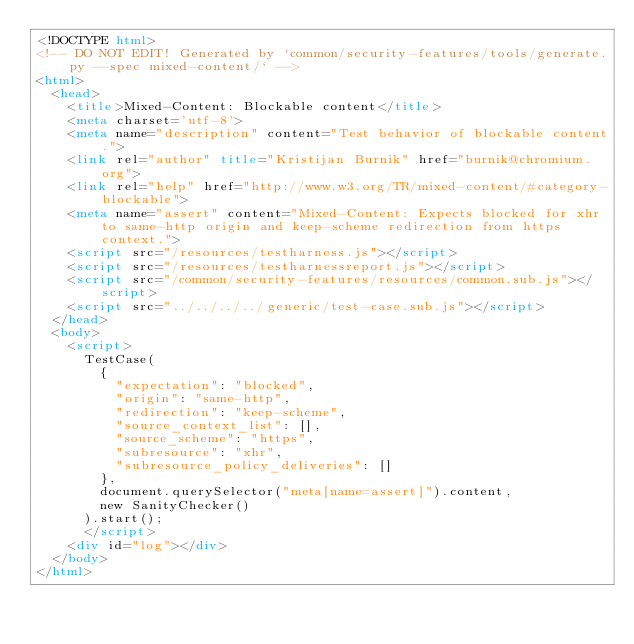Convert code to text. <code><loc_0><loc_0><loc_500><loc_500><_HTML_><!DOCTYPE html>
<!-- DO NOT EDIT! Generated by `common/security-features/tools/generate.py --spec mixed-content/` -->
<html>
  <head>
    <title>Mixed-Content: Blockable content</title>
    <meta charset='utf-8'>
    <meta name="description" content="Test behavior of blockable content.">
    <link rel="author" title="Kristijan Burnik" href="burnik@chromium.org">
    <link rel="help" href="http://www.w3.org/TR/mixed-content/#category-blockable">
    <meta name="assert" content="Mixed-Content: Expects blocked for xhr to same-http origin and keep-scheme redirection from https context.">
    <script src="/resources/testharness.js"></script>
    <script src="/resources/testharnessreport.js"></script>
    <script src="/common/security-features/resources/common.sub.js"></script>
    <script src="../../../../generic/test-case.sub.js"></script>
  </head>
  <body>
    <script>
      TestCase(
        {
          "expectation": "blocked",
          "origin": "same-http",
          "redirection": "keep-scheme",
          "source_context_list": [],
          "source_scheme": "https",
          "subresource": "xhr",
          "subresource_policy_deliveries": []
        },
        document.querySelector("meta[name=assert]").content,
        new SanityChecker()
      ).start();
      </script>
    <div id="log"></div>
  </body>
</html>
</code> 